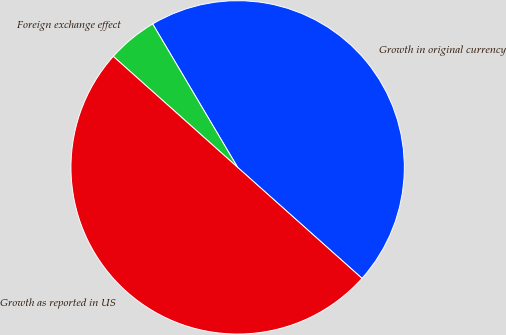Convert chart to OTSL. <chart><loc_0><loc_0><loc_500><loc_500><pie_chart><fcel>Growth in original currency<fcel>Foreign exchange effect<fcel>Growth as reported in US<nl><fcel>45.11%<fcel>4.89%<fcel>50.0%<nl></chart> 